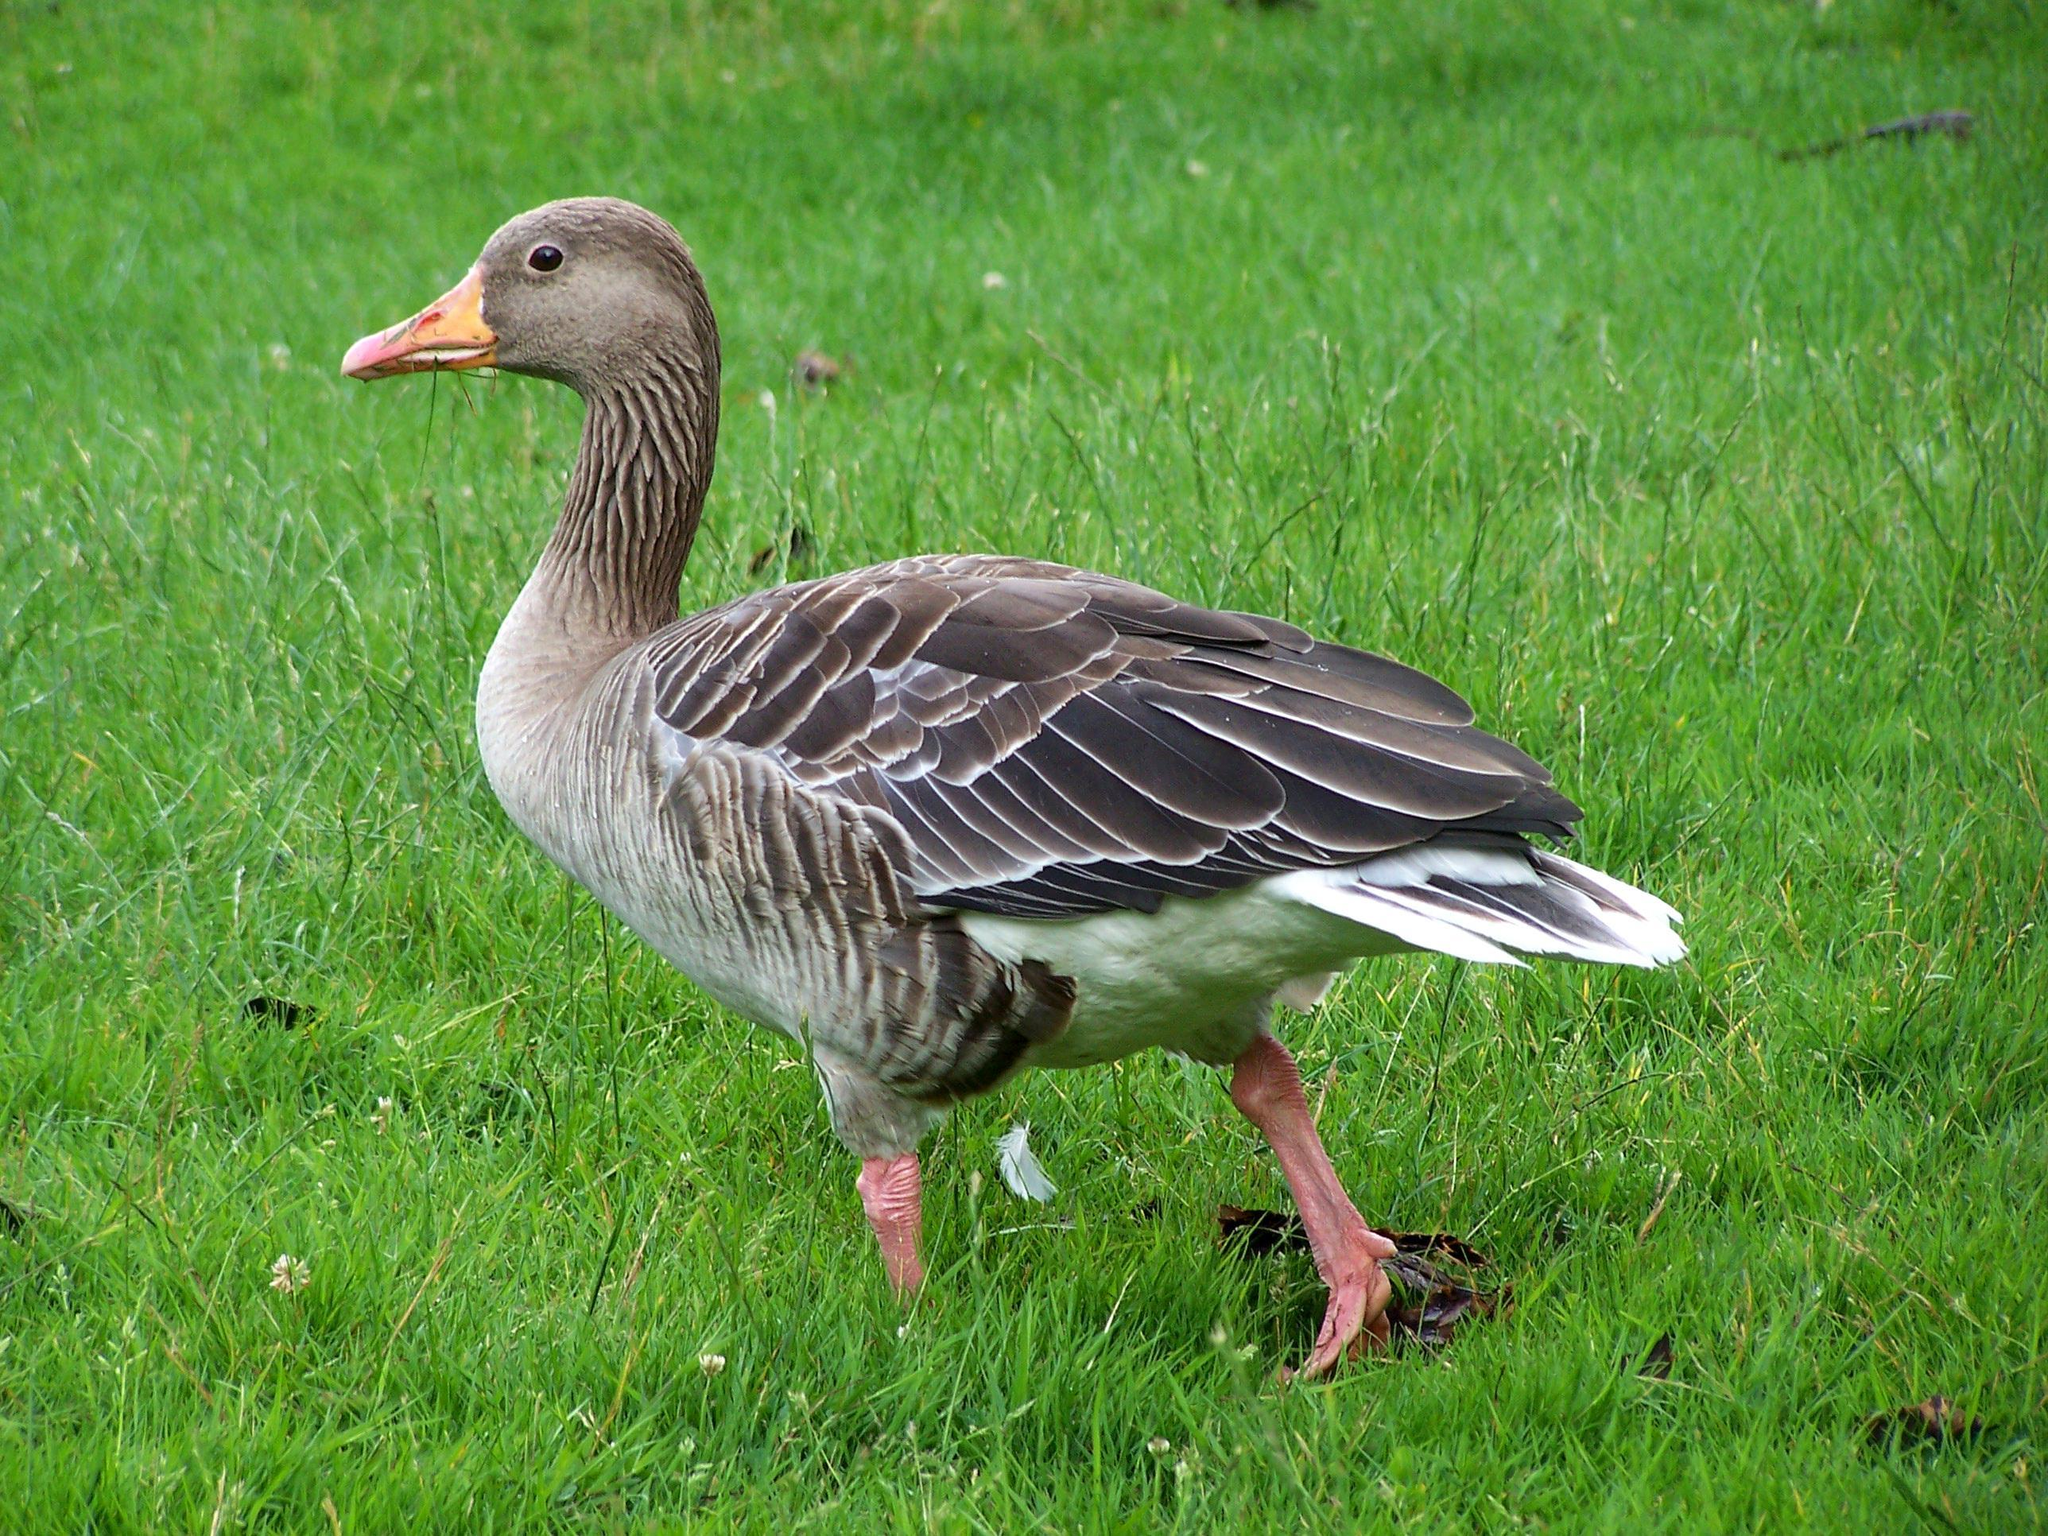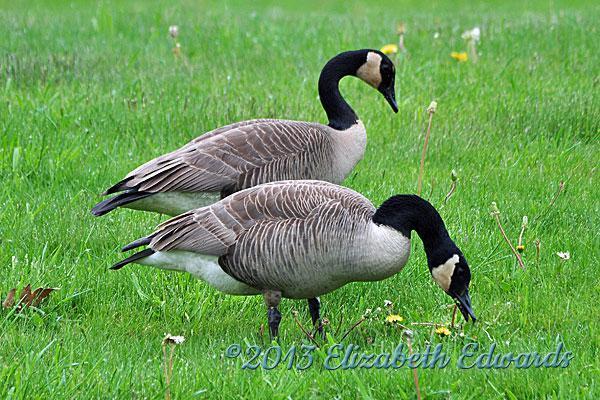The first image is the image on the left, the second image is the image on the right. For the images shown, is this caption "One image contains one grey goose with a grey neck who is standing upright with tucked wings, and the other image includes exactly two black necked geese with at least one bending its neck to the grass." true? Answer yes or no. Yes. The first image is the image on the left, the second image is the image on the right. Considering the images on both sides, is "One of the images features a single goose with an orange beak." valid? Answer yes or no. Yes. 